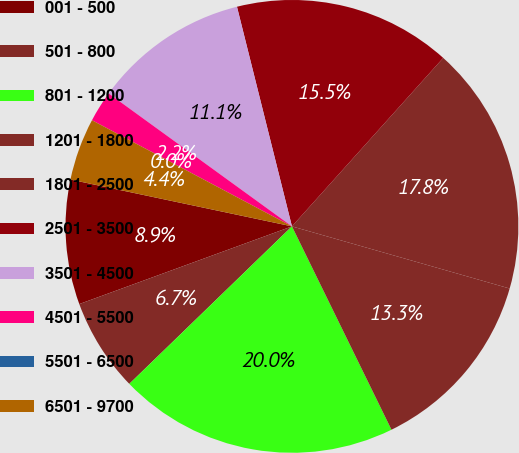Convert chart to OTSL. <chart><loc_0><loc_0><loc_500><loc_500><pie_chart><fcel>001 - 500<fcel>501 - 800<fcel>801 - 1200<fcel>1201 - 1800<fcel>1801 - 2500<fcel>2501 - 3500<fcel>3501 - 4500<fcel>4501 - 5500<fcel>5501 - 6500<fcel>6501 - 9700<nl><fcel>8.89%<fcel>6.67%<fcel>20.0%<fcel>13.33%<fcel>17.78%<fcel>15.55%<fcel>11.11%<fcel>2.22%<fcel>0.0%<fcel>4.45%<nl></chart> 